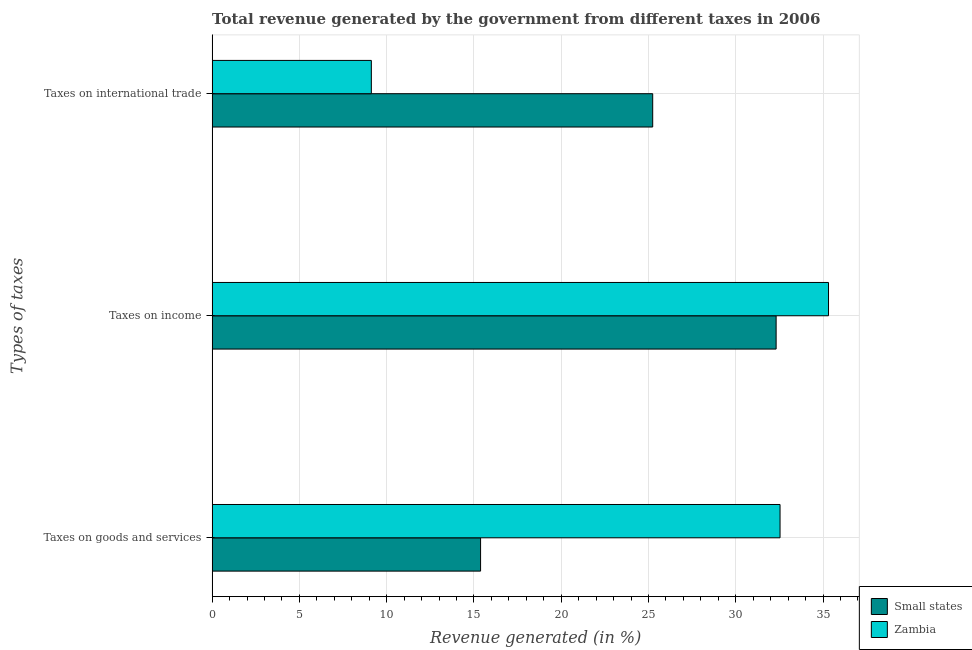How many different coloured bars are there?
Make the answer very short. 2. How many groups of bars are there?
Provide a short and direct response. 3. Are the number of bars per tick equal to the number of legend labels?
Provide a short and direct response. Yes. How many bars are there on the 1st tick from the top?
Offer a very short reply. 2. How many bars are there on the 3rd tick from the bottom?
Make the answer very short. 2. What is the label of the 2nd group of bars from the top?
Provide a succinct answer. Taxes on income. What is the percentage of revenue generated by tax on international trade in Zambia?
Keep it short and to the point. 9.12. Across all countries, what is the maximum percentage of revenue generated by tax on international trade?
Keep it short and to the point. 25.24. Across all countries, what is the minimum percentage of revenue generated by taxes on goods and services?
Make the answer very short. 15.38. In which country was the percentage of revenue generated by tax on international trade maximum?
Make the answer very short. Small states. In which country was the percentage of revenue generated by taxes on goods and services minimum?
Offer a terse response. Small states. What is the total percentage of revenue generated by taxes on income in the graph?
Offer a very short reply. 67.62. What is the difference between the percentage of revenue generated by taxes on income in Zambia and that in Small states?
Offer a very short reply. 3. What is the difference between the percentage of revenue generated by taxes on income in Small states and the percentage of revenue generated by tax on international trade in Zambia?
Offer a very short reply. 23.19. What is the average percentage of revenue generated by taxes on income per country?
Provide a short and direct response. 33.81. What is the difference between the percentage of revenue generated by taxes on goods and services and percentage of revenue generated by taxes on income in Zambia?
Provide a succinct answer. -2.78. In how many countries, is the percentage of revenue generated by taxes on income greater than 7 %?
Your answer should be compact. 2. What is the ratio of the percentage of revenue generated by tax on international trade in Small states to that in Zambia?
Your answer should be very brief. 2.77. Is the percentage of revenue generated by tax on international trade in Zambia less than that in Small states?
Ensure brevity in your answer.  Yes. What is the difference between the highest and the second highest percentage of revenue generated by tax on international trade?
Your answer should be very brief. 16.12. What is the difference between the highest and the lowest percentage of revenue generated by taxes on income?
Provide a short and direct response. 3. In how many countries, is the percentage of revenue generated by taxes on goods and services greater than the average percentage of revenue generated by taxes on goods and services taken over all countries?
Make the answer very short. 1. What does the 2nd bar from the top in Taxes on income represents?
Give a very brief answer. Small states. What does the 2nd bar from the bottom in Taxes on international trade represents?
Offer a terse response. Zambia. Is it the case that in every country, the sum of the percentage of revenue generated by taxes on goods and services and percentage of revenue generated by taxes on income is greater than the percentage of revenue generated by tax on international trade?
Offer a terse response. Yes. What is the difference between two consecutive major ticks on the X-axis?
Keep it short and to the point. 5. How are the legend labels stacked?
Offer a very short reply. Vertical. What is the title of the graph?
Provide a short and direct response. Total revenue generated by the government from different taxes in 2006. What is the label or title of the X-axis?
Your response must be concise. Revenue generated (in %). What is the label or title of the Y-axis?
Your response must be concise. Types of taxes. What is the Revenue generated (in %) of Small states in Taxes on goods and services?
Keep it short and to the point. 15.38. What is the Revenue generated (in %) of Zambia in Taxes on goods and services?
Make the answer very short. 32.54. What is the Revenue generated (in %) in Small states in Taxes on income?
Ensure brevity in your answer.  32.31. What is the Revenue generated (in %) of Zambia in Taxes on income?
Your answer should be compact. 35.31. What is the Revenue generated (in %) in Small states in Taxes on international trade?
Offer a very short reply. 25.24. What is the Revenue generated (in %) in Zambia in Taxes on international trade?
Offer a terse response. 9.12. Across all Types of taxes, what is the maximum Revenue generated (in %) in Small states?
Offer a very short reply. 32.31. Across all Types of taxes, what is the maximum Revenue generated (in %) in Zambia?
Provide a succinct answer. 35.31. Across all Types of taxes, what is the minimum Revenue generated (in %) in Small states?
Keep it short and to the point. 15.38. Across all Types of taxes, what is the minimum Revenue generated (in %) in Zambia?
Ensure brevity in your answer.  9.12. What is the total Revenue generated (in %) in Small states in the graph?
Provide a succinct answer. 72.93. What is the total Revenue generated (in %) in Zambia in the graph?
Make the answer very short. 76.97. What is the difference between the Revenue generated (in %) in Small states in Taxes on goods and services and that in Taxes on income?
Ensure brevity in your answer.  -16.93. What is the difference between the Revenue generated (in %) in Zambia in Taxes on goods and services and that in Taxes on income?
Make the answer very short. -2.78. What is the difference between the Revenue generated (in %) in Small states in Taxes on goods and services and that in Taxes on international trade?
Offer a terse response. -9.86. What is the difference between the Revenue generated (in %) in Zambia in Taxes on goods and services and that in Taxes on international trade?
Provide a succinct answer. 23.41. What is the difference between the Revenue generated (in %) in Small states in Taxes on income and that in Taxes on international trade?
Offer a very short reply. 7.07. What is the difference between the Revenue generated (in %) in Zambia in Taxes on income and that in Taxes on international trade?
Your answer should be compact. 26.19. What is the difference between the Revenue generated (in %) of Small states in Taxes on goods and services and the Revenue generated (in %) of Zambia in Taxes on income?
Your answer should be very brief. -19.93. What is the difference between the Revenue generated (in %) of Small states in Taxes on goods and services and the Revenue generated (in %) of Zambia in Taxes on international trade?
Keep it short and to the point. 6.26. What is the difference between the Revenue generated (in %) in Small states in Taxes on income and the Revenue generated (in %) in Zambia in Taxes on international trade?
Provide a succinct answer. 23.19. What is the average Revenue generated (in %) in Small states per Types of taxes?
Keep it short and to the point. 24.31. What is the average Revenue generated (in %) in Zambia per Types of taxes?
Your answer should be compact. 25.66. What is the difference between the Revenue generated (in %) in Small states and Revenue generated (in %) in Zambia in Taxes on goods and services?
Your response must be concise. -17.16. What is the difference between the Revenue generated (in %) in Small states and Revenue generated (in %) in Zambia in Taxes on income?
Give a very brief answer. -3. What is the difference between the Revenue generated (in %) of Small states and Revenue generated (in %) of Zambia in Taxes on international trade?
Give a very brief answer. 16.12. What is the ratio of the Revenue generated (in %) of Small states in Taxes on goods and services to that in Taxes on income?
Offer a very short reply. 0.48. What is the ratio of the Revenue generated (in %) in Zambia in Taxes on goods and services to that in Taxes on income?
Make the answer very short. 0.92. What is the ratio of the Revenue generated (in %) of Small states in Taxes on goods and services to that in Taxes on international trade?
Make the answer very short. 0.61. What is the ratio of the Revenue generated (in %) of Zambia in Taxes on goods and services to that in Taxes on international trade?
Offer a terse response. 3.57. What is the ratio of the Revenue generated (in %) of Small states in Taxes on income to that in Taxes on international trade?
Your answer should be compact. 1.28. What is the ratio of the Revenue generated (in %) in Zambia in Taxes on income to that in Taxes on international trade?
Ensure brevity in your answer.  3.87. What is the difference between the highest and the second highest Revenue generated (in %) of Small states?
Your answer should be very brief. 7.07. What is the difference between the highest and the second highest Revenue generated (in %) in Zambia?
Give a very brief answer. 2.78. What is the difference between the highest and the lowest Revenue generated (in %) in Small states?
Make the answer very short. 16.93. What is the difference between the highest and the lowest Revenue generated (in %) in Zambia?
Offer a terse response. 26.19. 